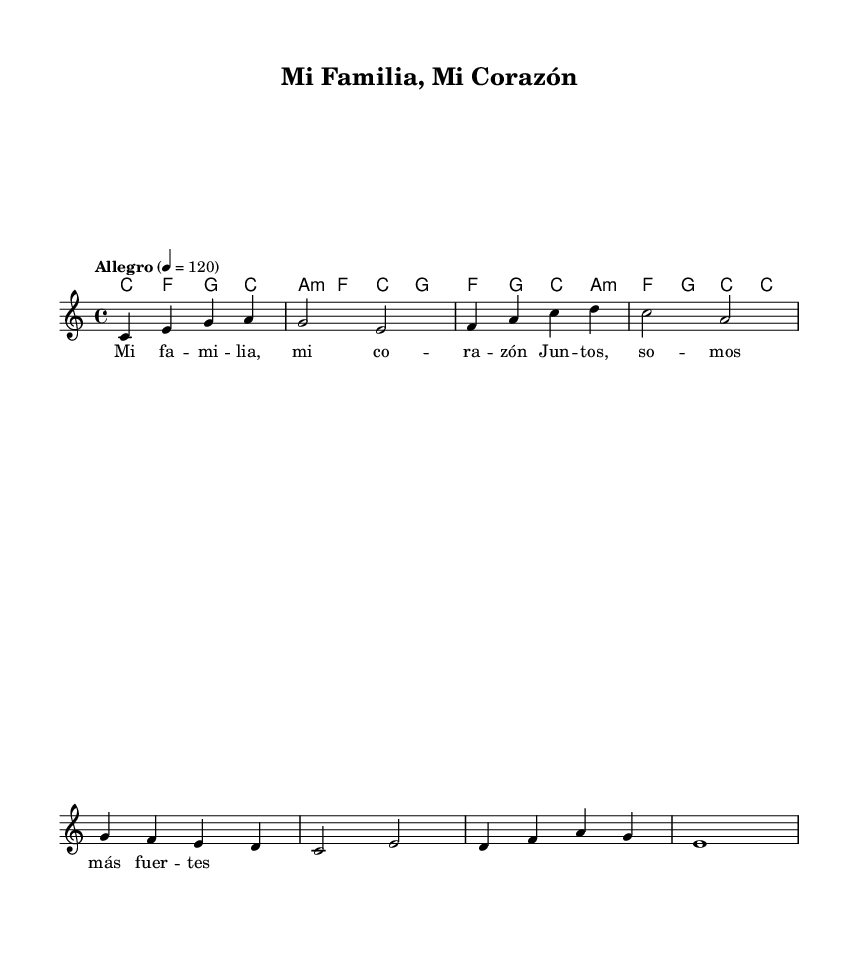What is the key signature of this music? The key signature is indicated at the beginning of the staff. This sheet music shows no sharps or flats, which designates it as C major.
Answer: C major What is the time signature of this music? The time signature appears at the beginning of the staff. It shows a "4/4" indication, meaning there are four beats per measure and a quarter note gets one beat.
Answer: 4/4 What is the tempo marking of the piece? The tempo marking is located under the title section and indicates "Allegro" with a metronome mark of 120 beats per minute, suggesting a fast and lively pace.
Answer: Allegro What are the first three notes of the melody? The first three notes of the melody can be identified from the melody staff. They are displayed as C, E, and G.
Answer: C, E, G How many measures are there in the melody? By counting the measures indicated by the bar lines in the melody staff, there are a total of eight measures.
Answer: Eight What chords are used in the first measure? In the first measure, the chord symbols show C major (C) is played, which matches the melody notes being sung simultaneously.
Answer: C What is the theme of the lyrics represented in the sheet music? The lyrics describe the concept of family and strength through unity, suggesting themes of love and connection, common in uplifting Latin music.
Answer: Family and strength 